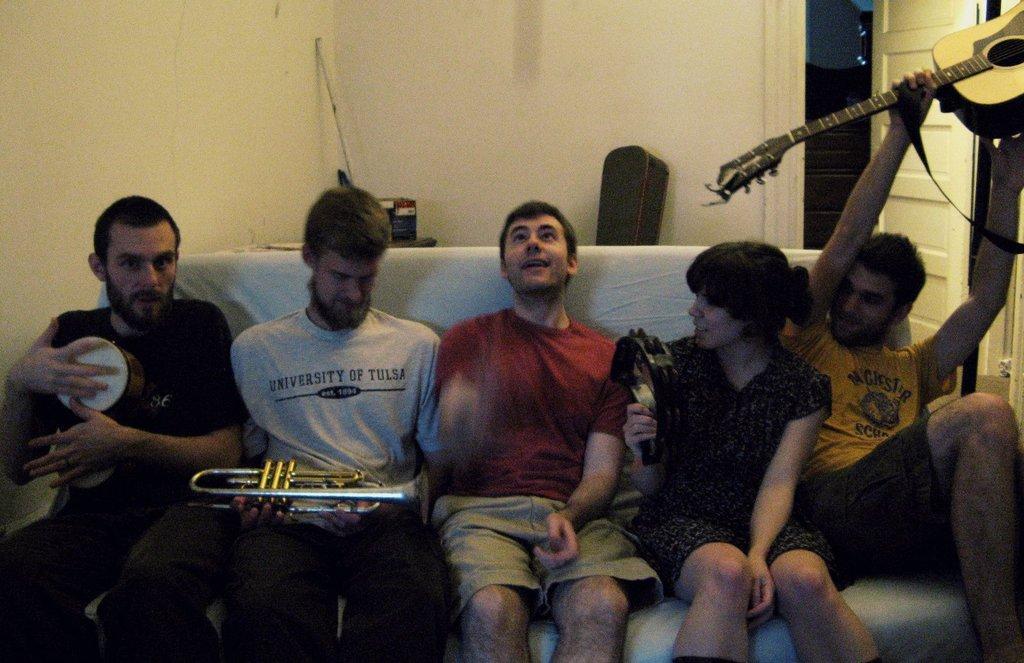Describe this image in one or two sentences. In this image, there are five persons sitting in a sofa. To the right, the man wearing yellow t-shirt is holding a guitar. To the left, the man sitting is holding a drum. In the background, there is a wall in white color and door. In the middle, the man is wearing red t-shirt. 